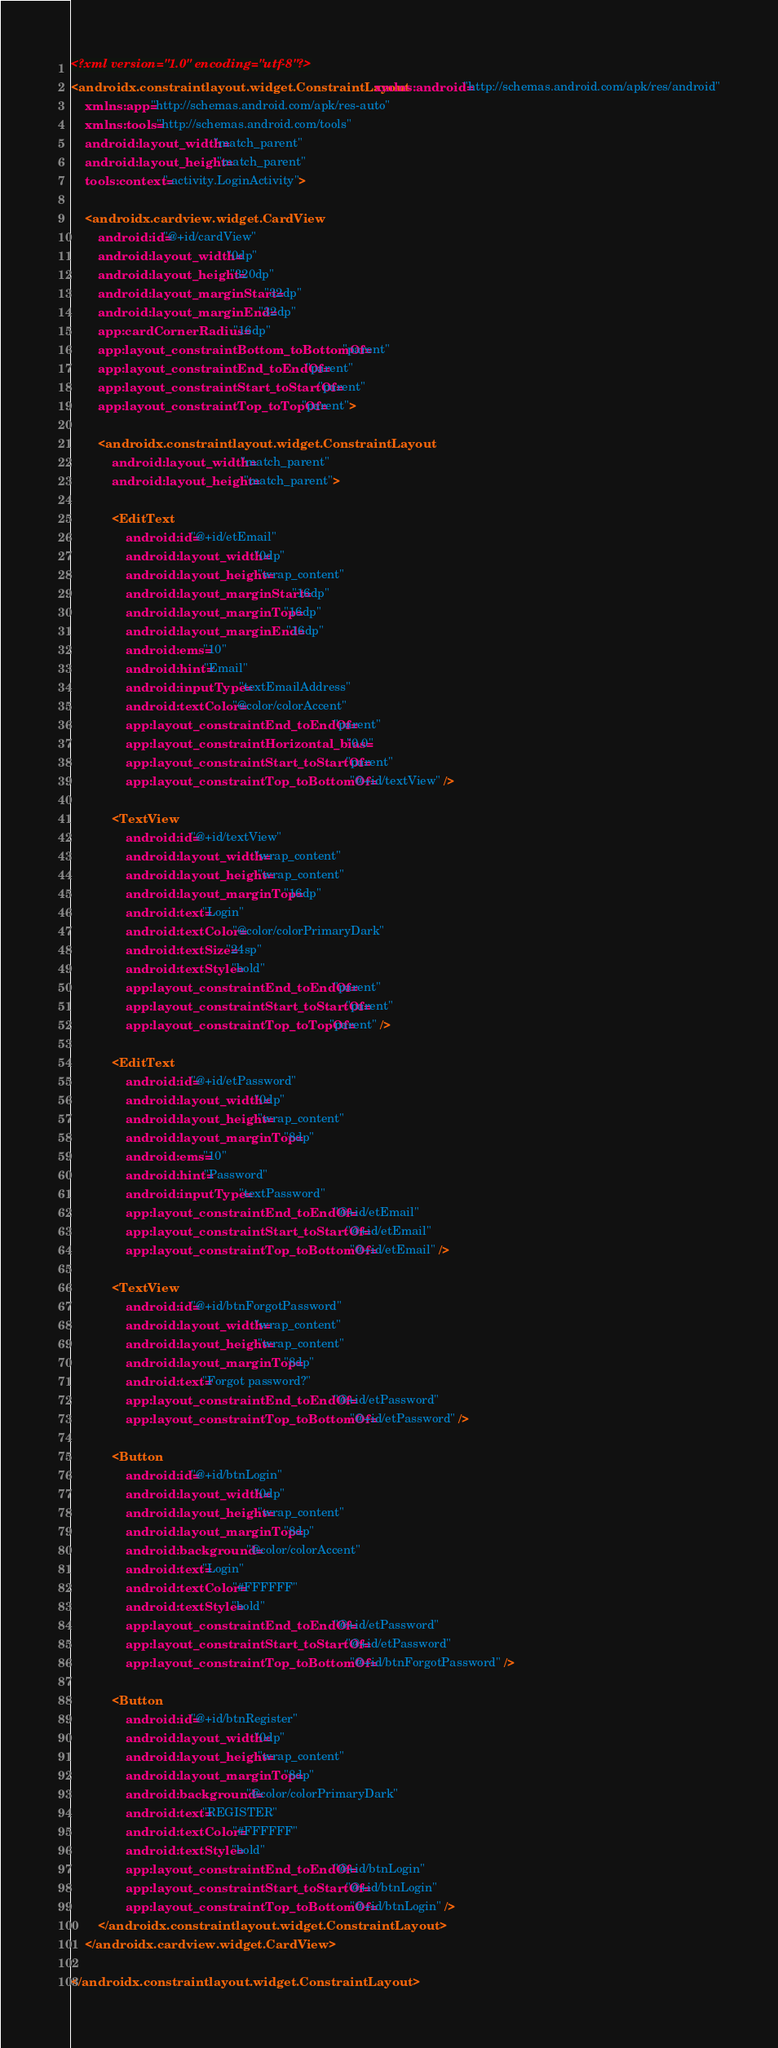Convert code to text. <code><loc_0><loc_0><loc_500><loc_500><_XML_><?xml version="1.0" encoding="utf-8"?>
<androidx.constraintlayout.widget.ConstraintLayout xmlns:android="http://schemas.android.com/apk/res/android"
    xmlns:app="http://schemas.android.com/apk/res-auto"
    xmlns:tools="http://schemas.android.com/tools"
    android:layout_width="match_parent"
    android:layout_height="match_parent"
    tools:context=".activity.LoginActivity">

    <androidx.cardview.widget.CardView
        android:id="@+id/cardView"
        android:layout_width="0dp"
        android:layout_height="320dp"
        android:layout_marginStart="32dp"
        android:layout_marginEnd="32dp"
        app:cardCornerRadius="16dp"
        app:layout_constraintBottom_toBottomOf="parent"
        app:layout_constraintEnd_toEndOf="parent"
        app:layout_constraintStart_toStartOf="parent"
        app:layout_constraintTop_toTopOf="parent">

        <androidx.constraintlayout.widget.ConstraintLayout
            android:layout_width="match_parent"
            android:layout_height="match_parent">

            <EditText
                android:id="@+id/etEmail"
                android:layout_width="0dp"
                android:layout_height="wrap_content"
                android:layout_marginStart="16dp"
                android:layout_marginTop="16dp"
                android:layout_marginEnd="16dp"
                android:ems="10"
                android:hint="Email"
                android:inputType="textEmailAddress"
                android:textColor="@color/colorAccent"
                app:layout_constraintEnd_toEndOf="parent"
                app:layout_constraintHorizontal_bias="0.0"
                app:layout_constraintStart_toStartOf="parent"
                app:layout_constraintTop_toBottomOf="@+id/textView" />

            <TextView
                android:id="@+id/textView"
                android:layout_width="wrap_content"
                android:layout_height="wrap_content"
                android:layout_marginTop="16dp"
                android:text="Login"
                android:textColor="@color/colorPrimaryDark"
                android:textSize="24sp"
                android:textStyle="bold"
                app:layout_constraintEnd_toEndOf="parent"
                app:layout_constraintStart_toStartOf="parent"
                app:layout_constraintTop_toTopOf="parent" />

            <EditText
                android:id="@+id/etPassword"
                android:layout_width="0dp"
                android:layout_height="wrap_content"
                android:layout_marginTop="8dp"
                android:ems="10"
                android:hint="Password"
                android:inputType="textPassword"
                app:layout_constraintEnd_toEndOf="@+id/etEmail"
                app:layout_constraintStart_toStartOf="@+id/etEmail"
                app:layout_constraintTop_toBottomOf="@+id/etEmail" />

            <TextView
                android:id="@+id/btnForgotPassword"
                android:layout_width="wrap_content"
                android:layout_height="wrap_content"
                android:layout_marginTop="8dp"
                android:text="Forgot password?"
                app:layout_constraintEnd_toEndOf="@+id/etPassword"
                app:layout_constraintTop_toBottomOf="@+id/etPassword" />

            <Button
                android:id="@+id/btnLogin"
                android:layout_width="0dp"
                android:layout_height="wrap_content"
                android:layout_marginTop="8dp"
                android:background="@color/colorAccent"
                android:text="Login"
                android:textColor="#FFFFFF"
                android:textStyle="bold"
                app:layout_constraintEnd_toEndOf="@+id/etPassword"
                app:layout_constraintStart_toStartOf="@+id/etPassword"
                app:layout_constraintTop_toBottomOf="@+id/btnForgotPassword" />

            <Button
                android:id="@+id/btnRegister"
                android:layout_width="0dp"
                android:layout_height="wrap_content"
                android:layout_marginTop="8dp"
                android:background="@color/colorPrimaryDark"
                android:text="REGISTER"
                android:textColor="#FFFFFF"
                android:textStyle="bold"
                app:layout_constraintEnd_toEndOf="@+id/btnLogin"
                app:layout_constraintStart_toStartOf="@+id/btnLogin"
                app:layout_constraintTop_toBottomOf="@+id/btnLogin" />
        </androidx.constraintlayout.widget.ConstraintLayout>
    </androidx.cardview.widget.CardView>

</androidx.constraintlayout.widget.ConstraintLayout></code> 